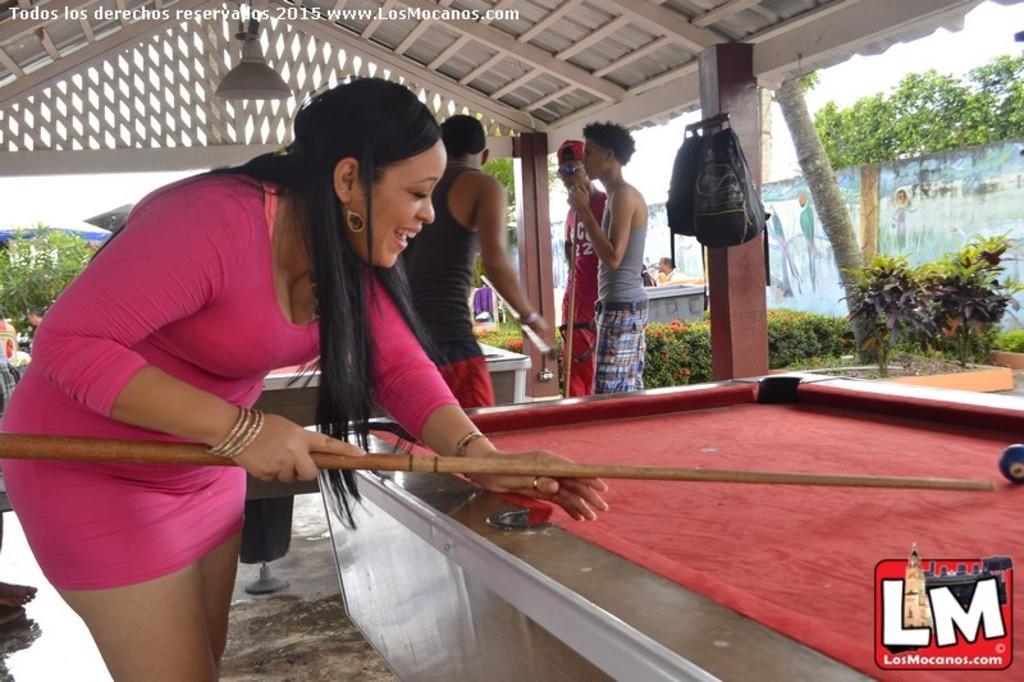Please provide a concise description of this image. In this picture there is a lady at the left side of the image and there is a board at the right side of the image, the lady is playing the game and there are other people those who are standing at the center of the image they are also playing the game, there are trees around the area of the image and there are two bags which are hanged at the right side of the image. 